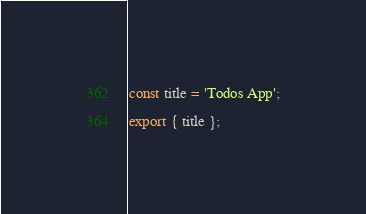<code> <loc_0><loc_0><loc_500><loc_500><_JavaScript_>const title = 'Todos App';

export { title };
</code> 